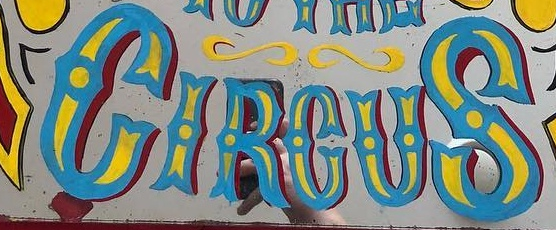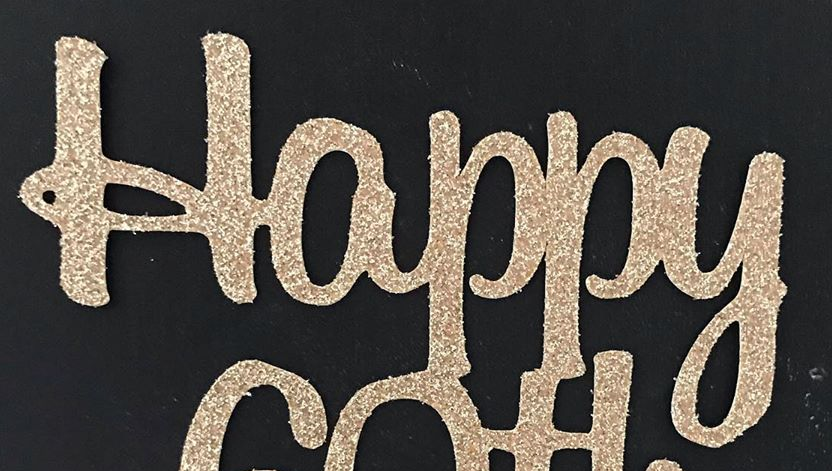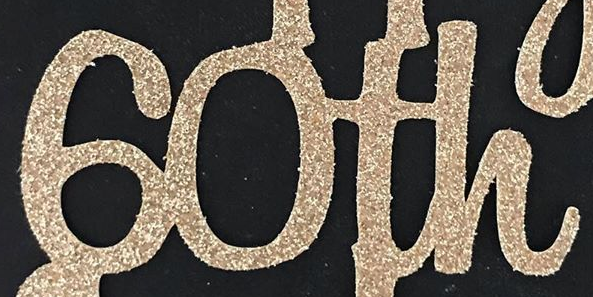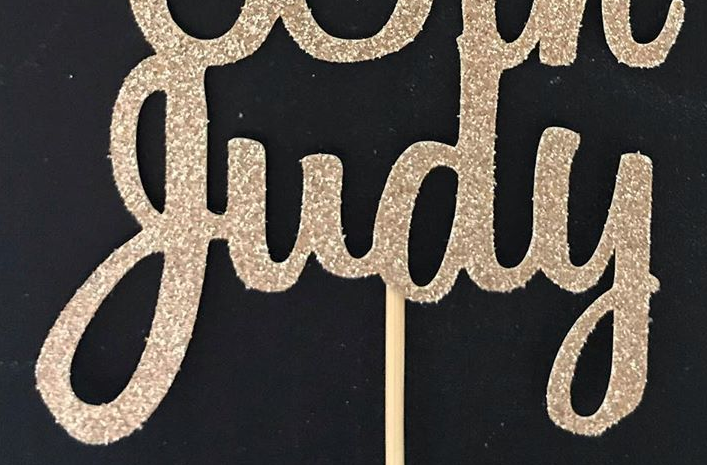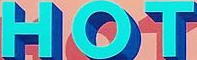What words are shown in these images in order, separated by a semicolon? CIRCUS; Happy; 60th; judy; HOT 